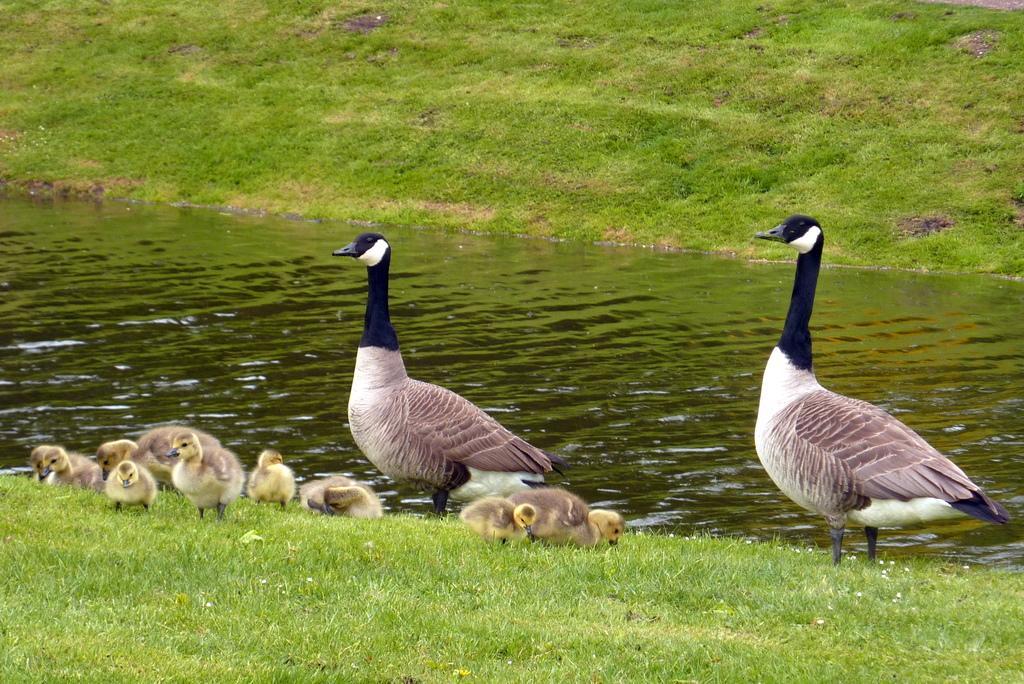Can you describe this image briefly? In this image we can see grass on both side of the image and water in the middle and there are few birds on the grass. 